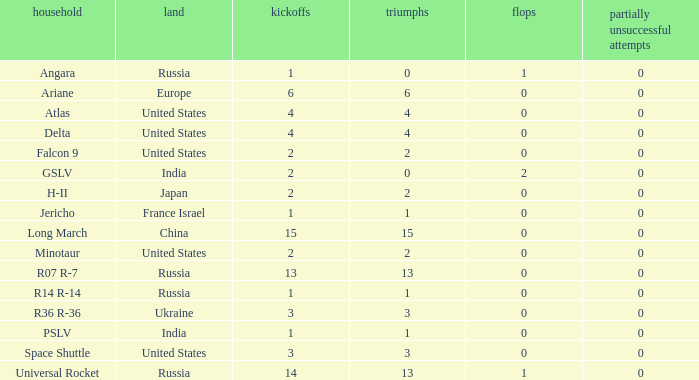What is the count of failure for the state of russia, and a family of r14 r-14, and a partial failures below 0? 0.0. 